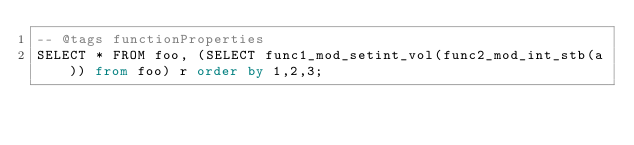Convert code to text. <code><loc_0><loc_0><loc_500><loc_500><_SQL_>-- @tags functionProperties 
SELECT * FROM foo, (SELECT func1_mod_setint_vol(func2_mod_int_stb(a)) from foo) r order by 1,2,3; 
</code> 